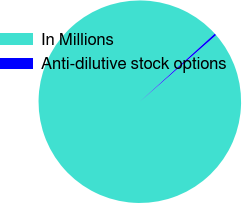Convert chart. <chart><loc_0><loc_0><loc_500><loc_500><pie_chart><fcel>In Millions<fcel>Anti-dilutive stock options<nl><fcel>99.69%<fcel>0.31%<nl></chart> 